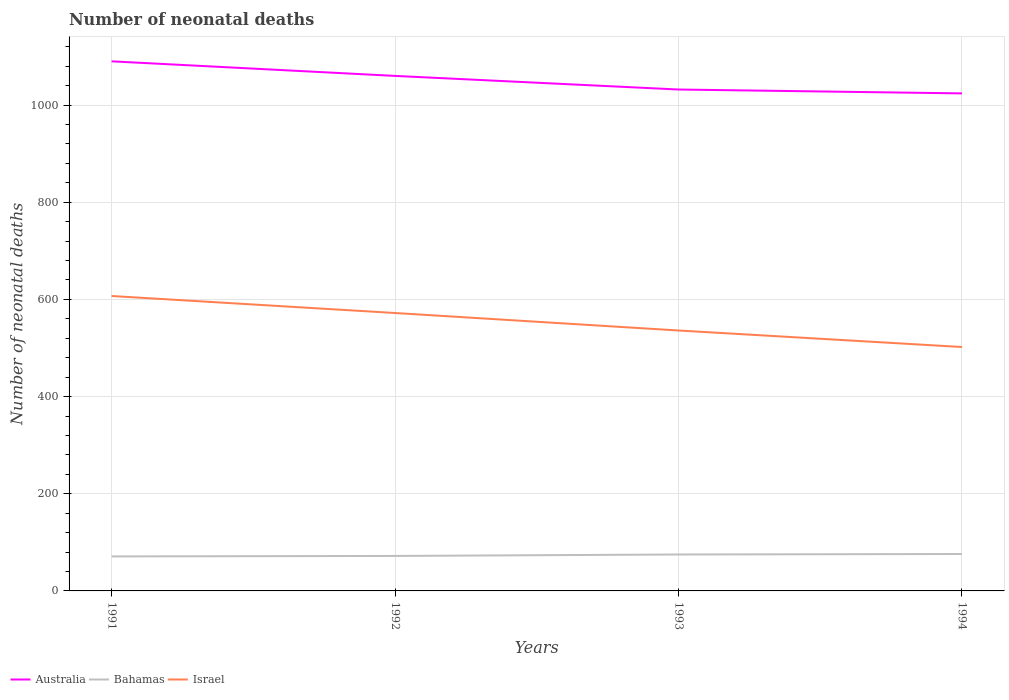How many different coloured lines are there?
Offer a terse response. 3. Does the line corresponding to Bahamas intersect with the line corresponding to Israel?
Provide a succinct answer. No. Is the number of lines equal to the number of legend labels?
Your answer should be very brief. Yes. Across all years, what is the maximum number of neonatal deaths in in Bahamas?
Provide a succinct answer. 71. In which year was the number of neonatal deaths in in Israel maximum?
Give a very brief answer. 1994. What is the total number of neonatal deaths in in Bahamas in the graph?
Provide a short and direct response. -1. What is the difference between the highest and the second highest number of neonatal deaths in in Bahamas?
Keep it short and to the point. 5. What is the difference between the highest and the lowest number of neonatal deaths in in Bahamas?
Keep it short and to the point. 2. How many lines are there?
Ensure brevity in your answer.  3. What is the difference between two consecutive major ticks on the Y-axis?
Offer a terse response. 200. Does the graph contain any zero values?
Offer a very short reply. No. Does the graph contain grids?
Keep it short and to the point. Yes. What is the title of the graph?
Your answer should be compact. Number of neonatal deaths. Does "Upper middle income" appear as one of the legend labels in the graph?
Ensure brevity in your answer.  No. What is the label or title of the X-axis?
Give a very brief answer. Years. What is the label or title of the Y-axis?
Offer a very short reply. Number of neonatal deaths. What is the Number of neonatal deaths of Australia in 1991?
Make the answer very short. 1090. What is the Number of neonatal deaths in Israel in 1991?
Keep it short and to the point. 607. What is the Number of neonatal deaths in Australia in 1992?
Provide a short and direct response. 1060. What is the Number of neonatal deaths in Bahamas in 1992?
Your answer should be very brief. 72. What is the Number of neonatal deaths of Israel in 1992?
Your answer should be compact. 572. What is the Number of neonatal deaths of Australia in 1993?
Make the answer very short. 1032. What is the Number of neonatal deaths of Israel in 1993?
Make the answer very short. 536. What is the Number of neonatal deaths in Australia in 1994?
Offer a terse response. 1024. What is the Number of neonatal deaths in Israel in 1994?
Offer a very short reply. 502. Across all years, what is the maximum Number of neonatal deaths of Australia?
Keep it short and to the point. 1090. Across all years, what is the maximum Number of neonatal deaths in Israel?
Your answer should be compact. 607. Across all years, what is the minimum Number of neonatal deaths of Australia?
Your response must be concise. 1024. Across all years, what is the minimum Number of neonatal deaths in Israel?
Provide a short and direct response. 502. What is the total Number of neonatal deaths of Australia in the graph?
Provide a short and direct response. 4206. What is the total Number of neonatal deaths of Bahamas in the graph?
Keep it short and to the point. 294. What is the total Number of neonatal deaths of Israel in the graph?
Provide a succinct answer. 2217. What is the difference between the Number of neonatal deaths in Australia in 1991 and that in 1992?
Provide a short and direct response. 30. What is the difference between the Number of neonatal deaths of Israel in 1991 and that in 1993?
Your answer should be very brief. 71. What is the difference between the Number of neonatal deaths of Australia in 1991 and that in 1994?
Provide a short and direct response. 66. What is the difference between the Number of neonatal deaths of Bahamas in 1991 and that in 1994?
Your response must be concise. -5. What is the difference between the Number of neonatal deaths in Israel in 1991 and that in 1994?
Your answer should be compact. 105. What is the difference between the Number of neonatal deaths of Australia in 1992 and that in 1993?
Keep it short and to the point. 28. What is the difference between the Number of neonatal deaths of Israel in 1992 and that in 1993?
Your response must be concise. 36. What is the difference between the Number of neonatal deaths in Australia in 1992 and that in 1994?
Give a very brief answer. 36. What is the difference between the Number of neonatal deaths in Israel in 1992 and that in 1994?
Keep it short and to the point. 70. What is the difference between the Number of neonatal deaths of Bahamas in 1993 and that in 1994?
Your response must be concise. -1. What is the difference between the Number of neonatal deaths in Israel in 1993 and that in 1994?
Offer a terse response. 34. What is the difference between the Number of neonatal deaths of Australia in 1991 and the Number of neonatal deaths of Bahamas in 1992?
Ensure brevity in your answer.  1018. What is the difference between the Number of neonatal deaths of Australia in 1991 and the Number of neonatal deaths of Israel in 1992?
Make the answer very short. 518. What is the difference between the Number of neonatal deaths in Bahamas in 1991 and the Number of neonatal deaths in Israel in 1992?
Provide a succinct answer. -501. What is the difference between the Number of neonatal deaths in Australia in 1991 and the Number of neonatal deaths in Bahamas in 1993?
Your answer should be compact. 1015. What is the difference between the Number of neonatal deaths in Australia in 1991 and the Number of neonatal deaths in Israel in 1993?
Offer a terse response. 554. What is the difference between the Number of neonatal deaths of Bahamas in 1991 and the Number of neonatal deaths of Israel in 1993?
Offer a very short reply. -465. What is the difference between the Number of neonatal deaths in Australia in 1991 and the Number of neonatal deaths in Bahamas in 1994?
Ensure brevity in your answer.  1014. What is the difference between the Number of neonatal deaths of Australia in 1991 and the Number of neonatal deaths of Israel in 1994?
Your answer should be compact. 588. What is the difference between the Number of neonatal deaths in Bahamas in 1991 and the Number of neonatal deaths in Israel in 1994?
Provide a short and direct response. -431. What is the difference between the Number of neonatal deaths of Australia in 1992 and the Number of neonatal deaths of Bahamas in 1993?
Offer a very short reply. 985. What is the difference between the Number of neonatal deaths of Australia in 1992 and the Number of neonatal deaths of Israel in 1993?
Keep it short and to the point. 524. What is the difference between the Number of neonatal deaths of Bahamas in 1992 and the Number of neonatal deaths of Israel in 1993?
Make the answer very short. -464. What is the difference between the Number of neonatal deaths in Australia in 1992 and the Number of neonatal deaths in Bahamas in 1994?
Give a very brief answer. 984. What is the difference between the Number of neonatal deaths in Australia in 1992 and the Number of neonatal deaths in Israel in 1994?
Keep it short and to the point. 558. What is the difference between the Number of neonatal deaths of Bahamas in 1992 and the Number of neonatal deaths of Israel in 1994?
Your answer should be very brief. -430. What is the difference between the Number of neonatal deaths in Australia in 1993 and the Number of neonatal deaths in Bahamas in 1994?
Keep it short and to the point. 956. What is the difference between the Number of neonatal deaths of Australia in 1993 and the Number of neonatal deaths of Israel in 1994?
Offer a very short reply. 530. What is the difference between the Number of neonatal deaths in Bahamas in 1993 and the Number of neonatal deaths in Israel in 1994?
Provide a short and direct response. -427. What is the average Number of neonatal deaths in Australia per year?
Provide a succinct answer. 1051.5. What is the average Number of neonatal deaths in Bahamas per year?
Make the answer very short. 73.5. What is the average Number of neonatal deaths in Israel per year?
Your answer should be very brief. 554.25. In the year 1991, what is the difference between the Number of neonatal deaths in Australia and Number of neonatal deaths in Bahamas?
Give a very brief answer. 1019. In the year 1991, what is the difference between the Number of neonatal deaths in Australia and Number of neonatal deaths in Israel?
Offer a very short reply. 483. In the year 1991, what is the difference between the Number of neonatal deaths of Bahamas and Number of neonatal deaths of Israel?
Provide a short and direct response. -536. In the year 1992, what is the difference between the Number of neonatal deaths of Australia and Number of neonatal deaths of Bahamas?
Keep it short and to the point. 988. In the year 1992, what is the difference between the Number of neonatal deaths in Australia and Number of neonatal deaths in Israel?
Keep it short and to the point. 488. In the year 1992, what is the difference between the Number of neonatal deaths in Bahamas and Number of neonatal deaths in Israel?
Your answer should be compact. -500. In the year 1993, what is the difference between the Number of neonatal deaths of Australia and Number of neonatal deaths of Bahamas?
Provide a succinct answer. 957. In the year 1993, what is the difference between the Number of neonatal deaths in Australia and Number of neonatal deaths in Israel?
Provide a short and direct response. 496. In the year 1993, what is the difference between the Number of neonatal deaths in Bahamas and Number of neonatal deaths in Israel?
Offer a very short reply. -461. In the year 1994, what is the difference between the Number of neonatal deaths in Australia and Number of neonatal deaths in Bahamas?
Keep it short and to the point. 948. In the year 1994, what is the difference between the Number of neonatal deaths of Australia and Number of neonatal deaths of Israel?
Offer a very short reply. 522. In the year 1994, what is the difference between the Number of neonatal deaths in Bahamas and Number of neonatal deaths in Israel?
Your response must be concise. -426. What is the ratio of the Number of neonatal deaths in Australia in 1991 to that in 1992?
Provide a short and direct response. 1.03. What is the ratio of the Number of neonatal deaths of Bahamas in 1991 to that in 1992?
Your answer should be very brief. 0.99. What is the ratio of the Number of neonatal deaths of Israel in 1991 to that in 1992?
Make the answer very short. 1.06. What is the ratio of the Number of neonatal deaths of Australia in 1991 to that in 1993?
Your answer should be compact. 1.06. What is the ratio of the Number of neonatal deaths in Bahamas in 1991 to that in 1993?
Offer a terse response. 0.95. What is the ratio of the Number of neonatal deaths in Israel in 1991 to that in 1993?
Offer a terse response. 1.13. What is the ratio of the Number of neonatal deaths in Australia in 1991 to that in 1994?
Keep it short and to the point. 1.06. What is the ratio of the Number of neonatal deaths of Bahamas in 1991 to that in 1994?
Your response must be concise. 0.93. What is the ratio of the Number of neonatal deaths in Israel in 1991 to that in 1994?
Your answer should be very brief. 1.21. What is the ratio of the Number of neonatal deaths of Australia in 1992 to that in 1993?
Provide a short and direct response. 1.03. What is the ratio of the Number of neonatal deaths in Israel in 1992 to that in 1993?
Your answer should be very brief. 1.07. What is the ratio of the Number of neonatal deaths in Australia in 1992 to that in 1994?
Ensure brevity in your answer.  1.04. What is the ratio of the Number of neonatal deaths in Bahamas in 1992 to that in 1994?
Keep it short and to the point. 0.95. What is the ratio of the Number of neonatal deaths of Israel in 1992 to that in 1994?
Your answer should be very brief. 1.14. What is the ratio of the Number of neonatal deaths in Australia in 1993 to that in 1994?
Provide a succinct answer. 1.01. What is the ratio of the Number of neonatal deaths of Israel in 1993 to that in 1994?
Offer a very short reply. 1.07. What is the difference between the highest and the second highest Number of neonatal deaths in Australia?
Your response must be concise. 30. What is the difference between the highest and the second highest Number of neonatal deaths of Bahamas?
Your answer should be very brief. 1. What is the difference between the highest and the second highest Number of neonatal deaths of Israel?
Give a very brief answer. 35. What is the difference between the highest and the lowest Number of neonatal deaths of Bahamas?
Your answer should be compact. 5. What is the difference between the highest and the lowest Number of neonatal deaths of Israel?
Offer a terse response. 105. 